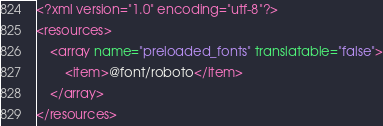<code> <loc_0><loc_0><loc_500><loc_500><_XML_><?xml version="1.0" encoding="utf-8"?>
<resources>
    <array name="preloaded_fonts" translatable="false">
        <item>@font/roboto</item>
    </array>
</resources>
</code> 